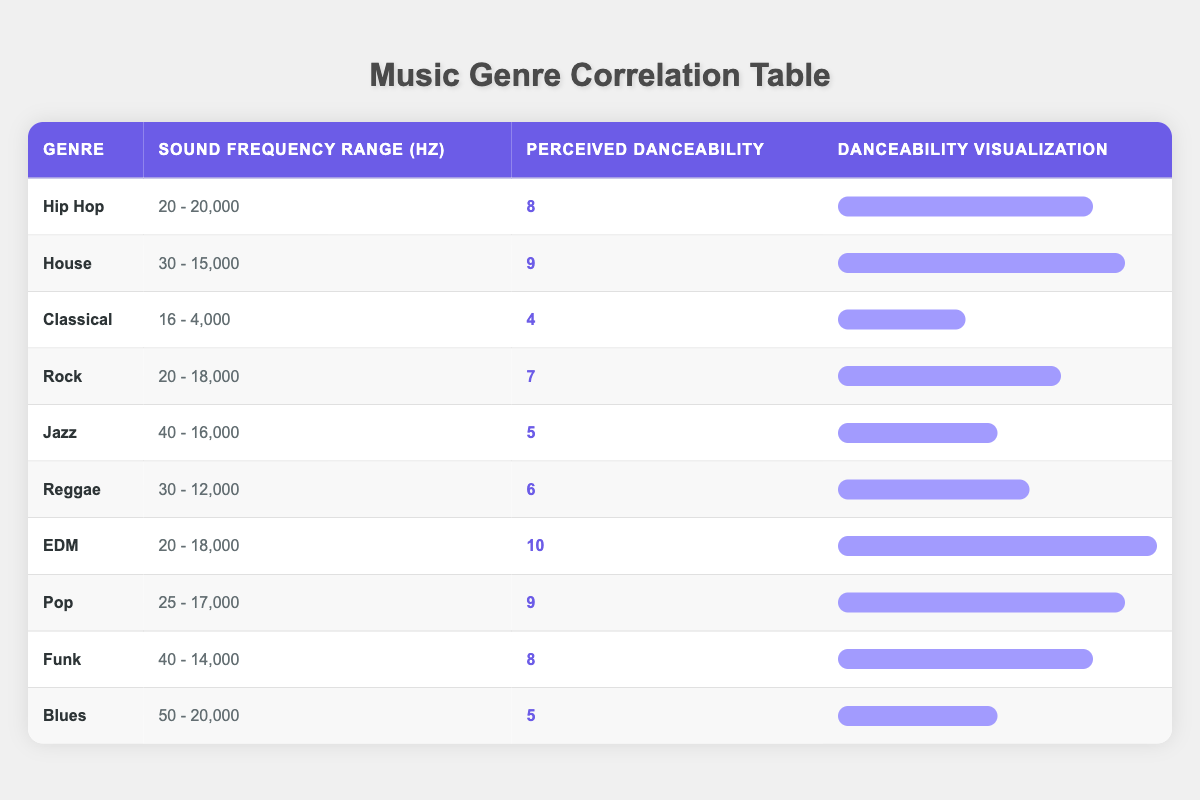What is the perceived danceability of the EDM genre? According to the table, the perceived danceability for the EDM genre is explicitly listed as 10.
Answer: 10 Which genre has the lowest perceived danceability? By inspecting the table, Classical has the lowest perceived danceability at 4.
Answer: Classical What is the sound frequency range of the Pop genre? The table specifies the sound frequency range for Pop as 25 - 17,000 Hz.
Answer: 25 - 17,000 Is the perceived danceability of Funk greater than that of Jazz? Funk has a perceived danceability of 8, while Jazz has a perceived danceability of 5. Since 8 is greater than 5, the answer is yes.
Answer: Yes What is the average perceived danceability of genres with a sound frequency range that exceeds 15,000 Hz? The genres with sound frequency ranges exceeding 15,000 Hz are Hip Hop (8), EDM (10), Blues (5), and Pop (9). Adding these up gives us 8 + 10 + 5 + 9 = 32. Since there are 4 genres, the average is 32 / 4 = 8.
Answer: 8 Which genres have the same perceived danceability score? By reviewing the table, Hip Hop (8) and Funk (8) share the same perceived danceability score.
Answer: Hip Hop, Funk What is the highest sound frequency range reported in the table? The highest sound frequency range listed is 20 - 20,000 Hz for Hip Hop and Blues.
Answer: 20 - 20,000 What is the difference in perceived danceability between House and Reggae? The perceived danceability for House is 9 and for Reggae is 6. The difference is calculated as 9 - 6 = 3.
Answer: 3 Do all genres listed have a perceived danceability score above 4? Evaluating the table shows that Classical (4) has a score equal to 4, so not all genres exceed this score.
Answer: No 